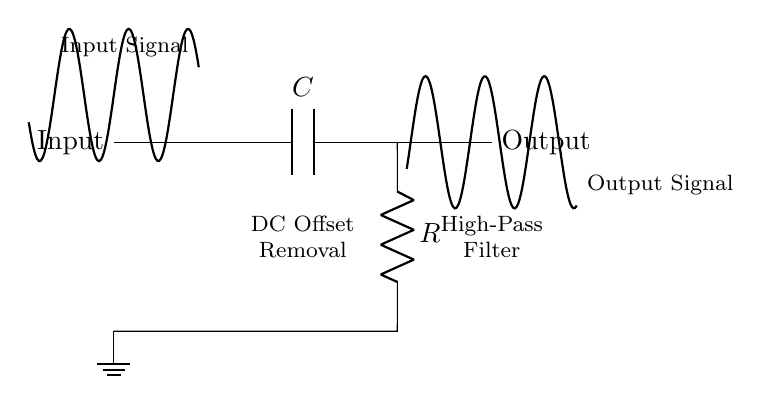What is the type of filter represented in this circuit? The circuit is identified as a high-pass filter, as indicated by the capacitor connected at the input which allows high-frequency signals to pass while attenuating lower frequencies, including DC.
Answer: High-pass filter What is the purpose of the capacitor in this circuit? The role of the capacitor is to block direct current (DC) while allowing alternating current (AC) signals to pass through, thereby removing any DC offset from the input signal.
Answer: Remove DC offset Which component is responsible for the frequency response? The frequency response is influenced by the combination of the resistor and capacitor, which together determine the cutoff frequency of the filter.
Answer: Resistor and capacitor What happens to the input signal at the output? The output signal will reflect only the AC components of the input signal after the DC offset has been removed, resulting in a waveform that oscillates around zero volts.
Answer: AC component only What is the function of the resistor in this circuit? The resistor works in conjunction with the capacitor to define the time constant of the circuit, which influences how quickly the circuit can respond to changes in the input signal and contributes to the filter's cutoff frequency.
Answer: Define time constant What can be said about the output compared to the input in terms of DC components? The output signal contains no DC components, as the high-pass filter's design effectively eliminates any DC offset present in the input signal.
Answer: No DC components What does the label "DC Offset Removal" signify in the circuit? This label indicates that the primary purpose of this circuit configuration is to eliminate any unwanted direct current level present in the input audio signal, allowing for a cleaner audio output.
Answer: Eliminate unwanted DC level 